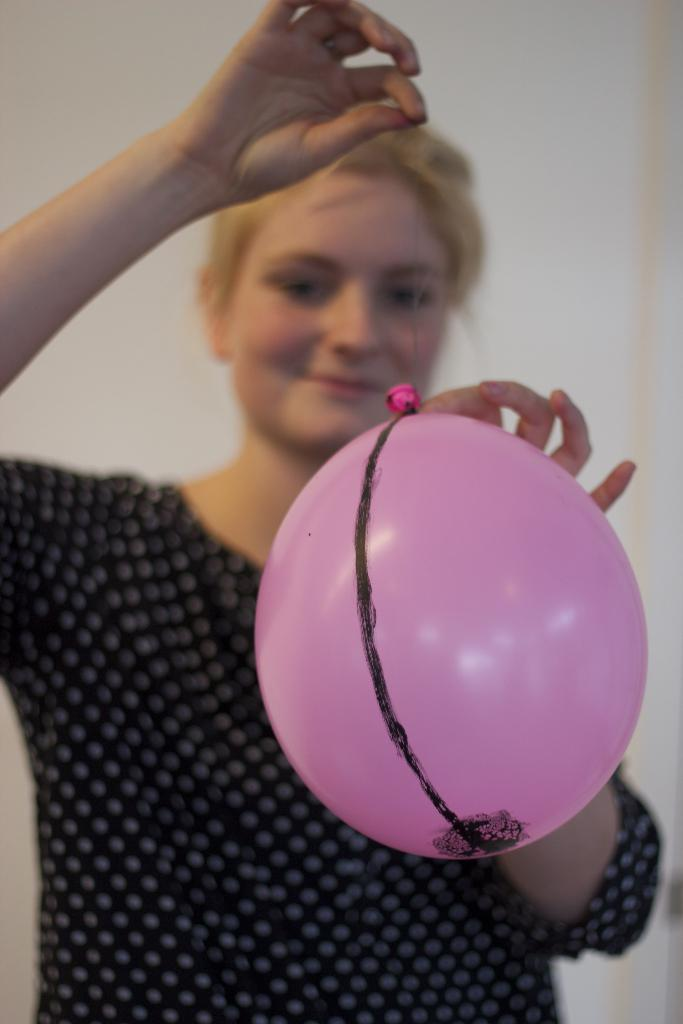What is the main subject of the image? The main subject of the image is a woman. What is the woman holding in her hands? The woman is holding a balloon in her hands. What type of corn can be seen growing in the background of the image? There is no corn visible in the image; it only features a woman holding a balloon. 